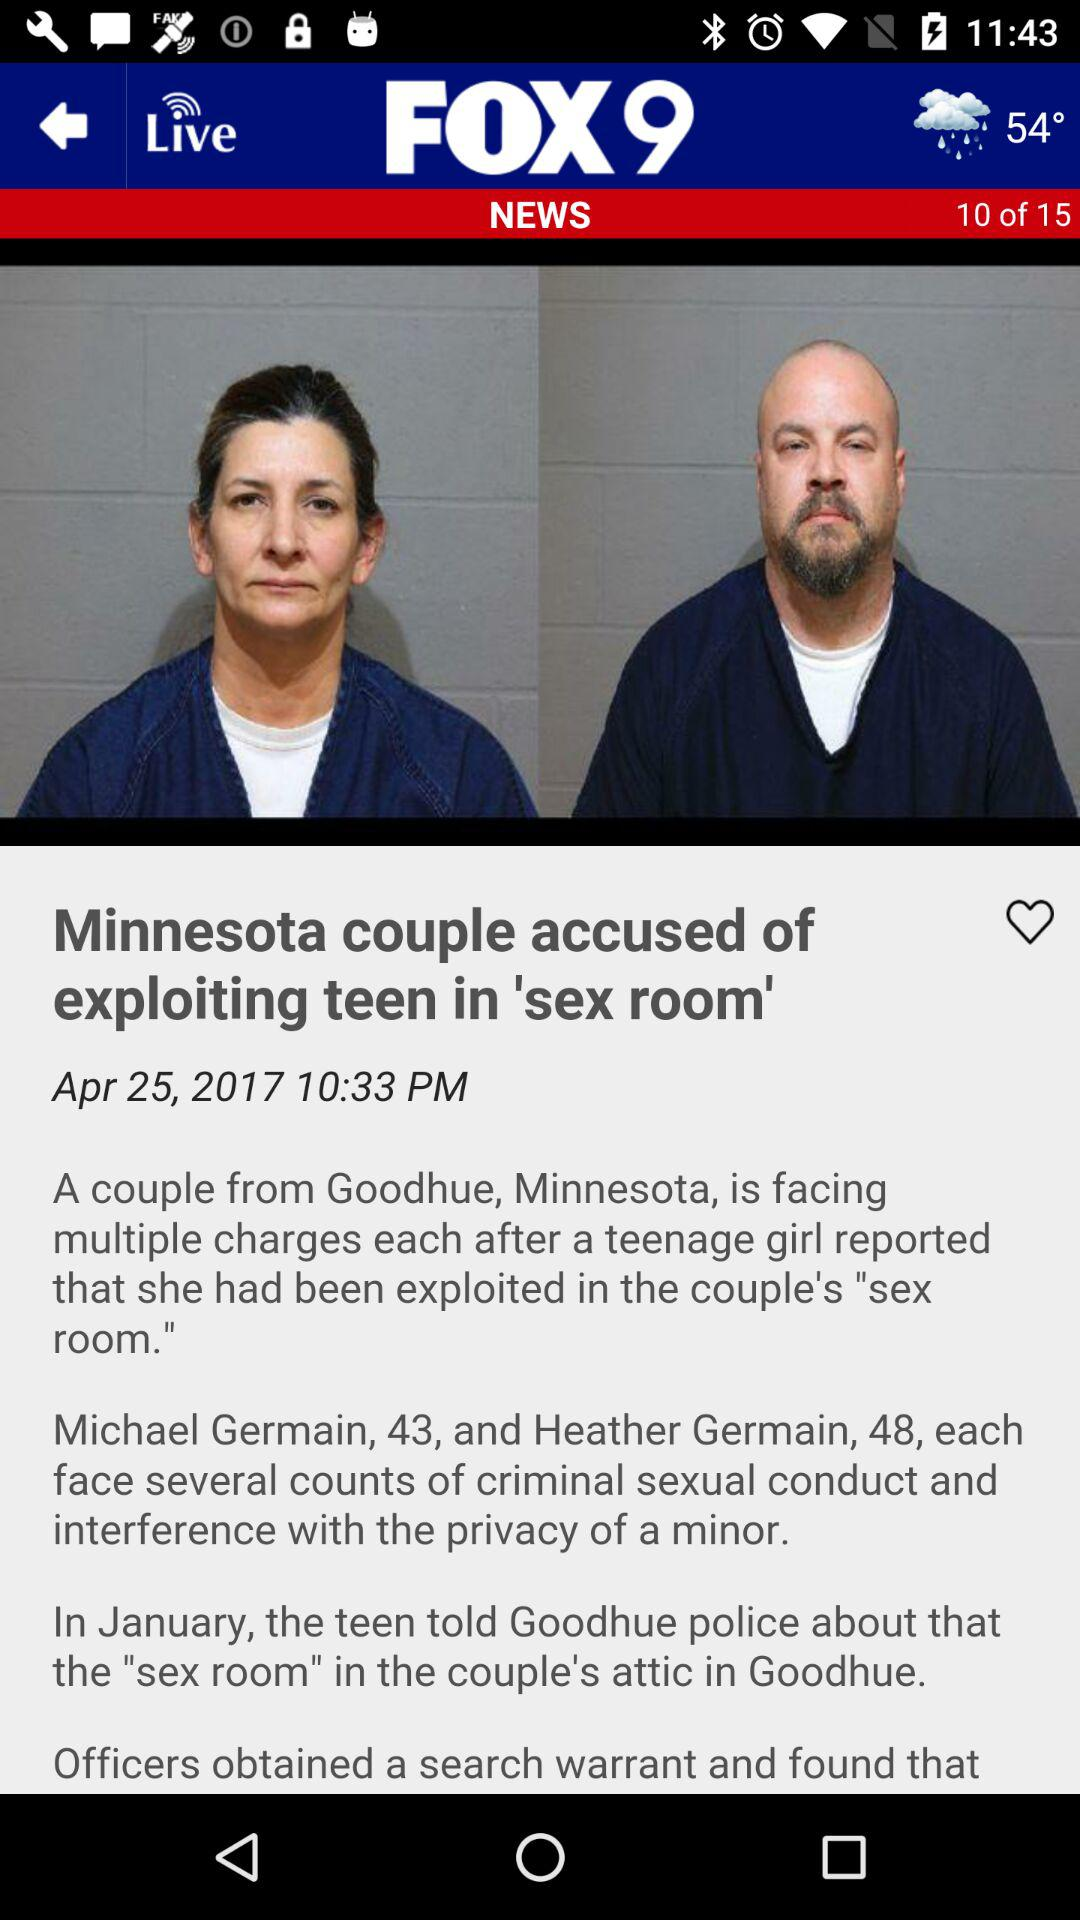What is the date? The date is April 25, 2017. 